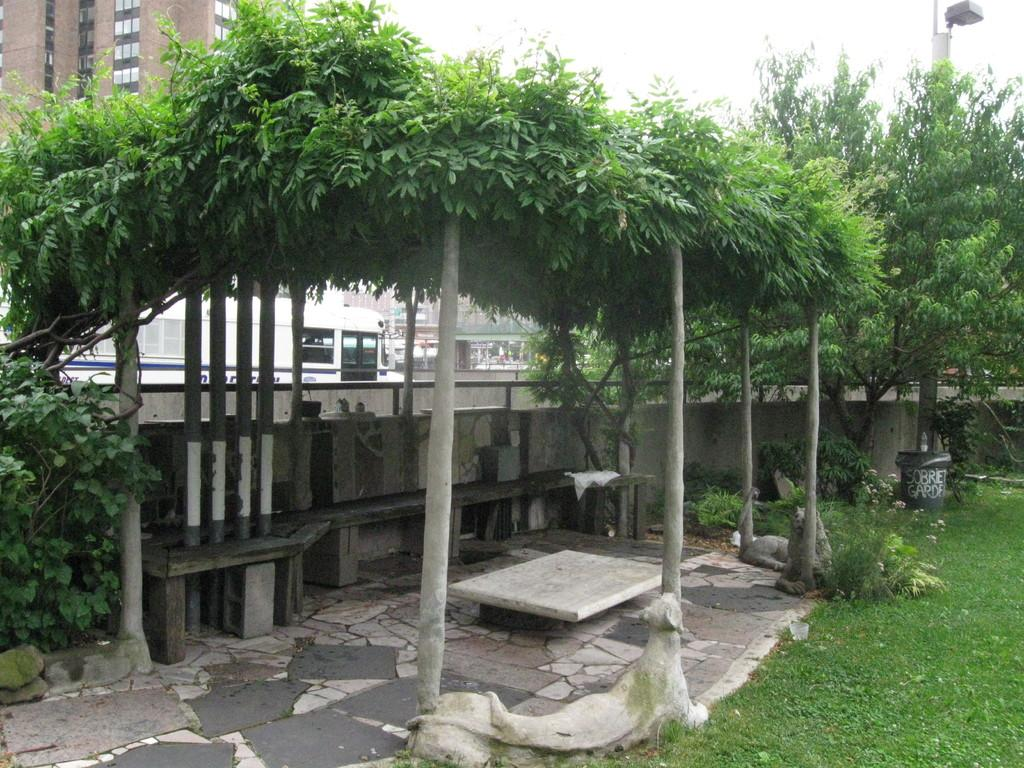What type of seating is present in the image? There is a bench in the image. What is located above the bench? There are trees above the bench. What can be seen on the ground in the image? The ground is visible and has greenery in the right corner. What is visible in the background of the image? There is a building in the background of the image. What statement does the police officer make while standing next to the bench in the image? There is no police officer present in the image, so no statement can be attributed to one. 